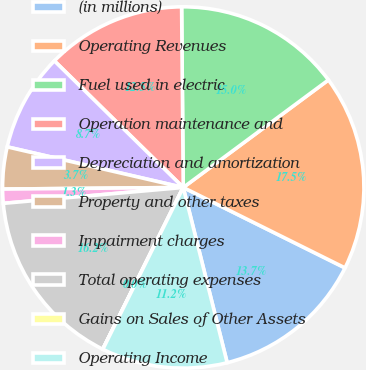Convert chart. <chart><loc_0><loc_0><loc_500><loc_500><pie_chart><fcel>(in millions)<fcel>Operating Revenues<fcel>Fuel used in electric<fcel>Operation maintenance and<fcel>Depreciation and amortization<fcel>Property and other taxes<fcel>Impairment charges<fcel>Total operating expenses<fcel>Gains on Sales of Other Assets<fcel>Operating Income<nl><fcel>13.75%<fcel>17.49%<fcel>15.0%<fcel>12.5%<fcel>8.75%<fcel>3.75%<fcel>1.26%<fcel>16.25%<fcel>0.01%<fcel>11.25%<nl></chart> 